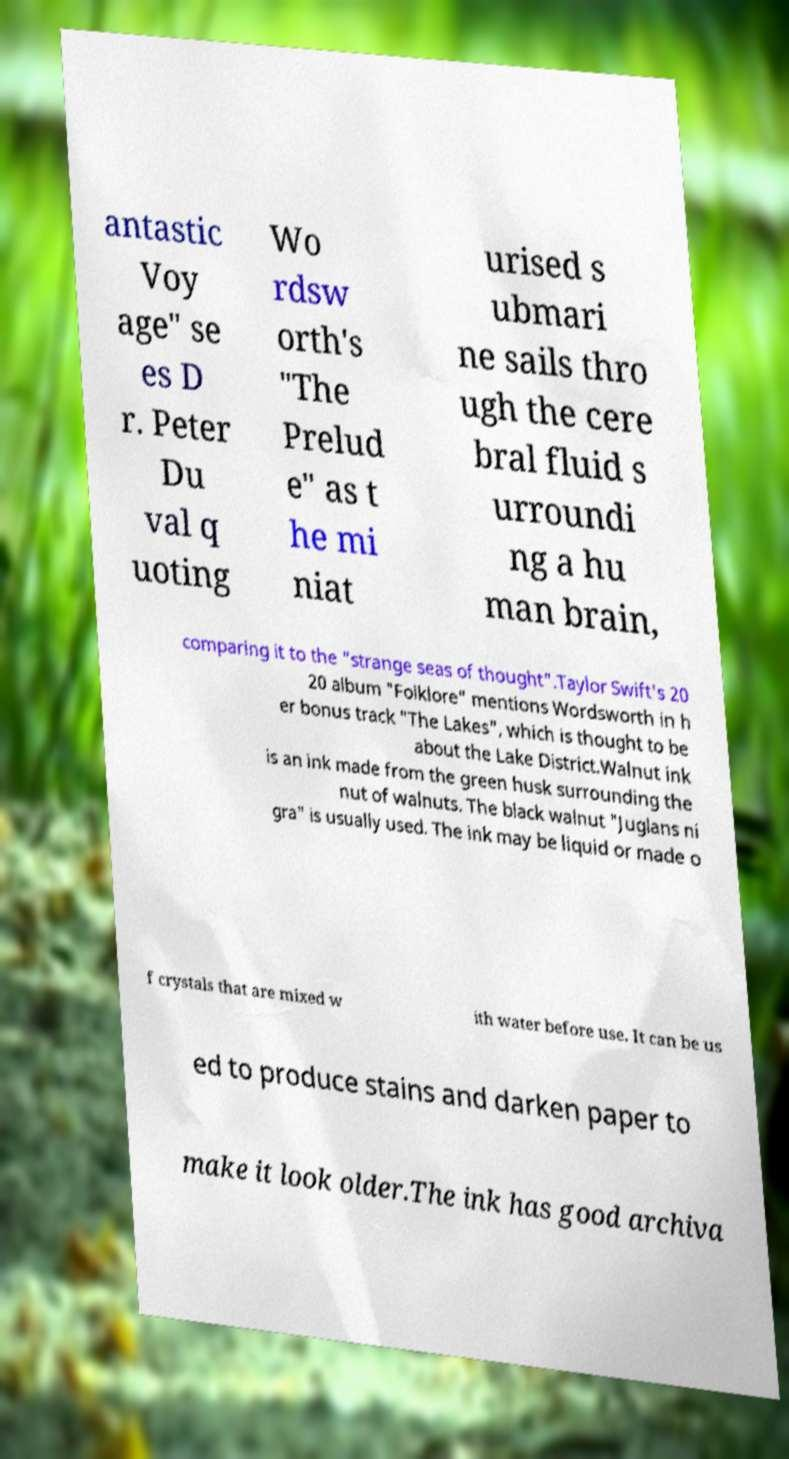Could you extract and type out the text from this image? antastic Voy age" se es D r. Peter Du val q uoting Wo rdsw orth's "The Prelud e" as t he mi niat urised s ubmari ne sails thro ugh the cere bral fluid s urroundi ng a hu man brain, comparing it to the "strange seas of thought".Taylor Swift's 20 20 album "Folklore" mentions Wordsworth in h er bonus track "The Lakes", which is thought to be about the Lake District.Walnut ink is an ink made from the green husk surrounding the nut of walnuts. The black walnut "Juglans ni gra" is usually used. The ink may be liquid or made o f crystals that are mixed w ith water before use. It can be us ed to produce stains and darken paper to make it look older.The ink has good archiva 